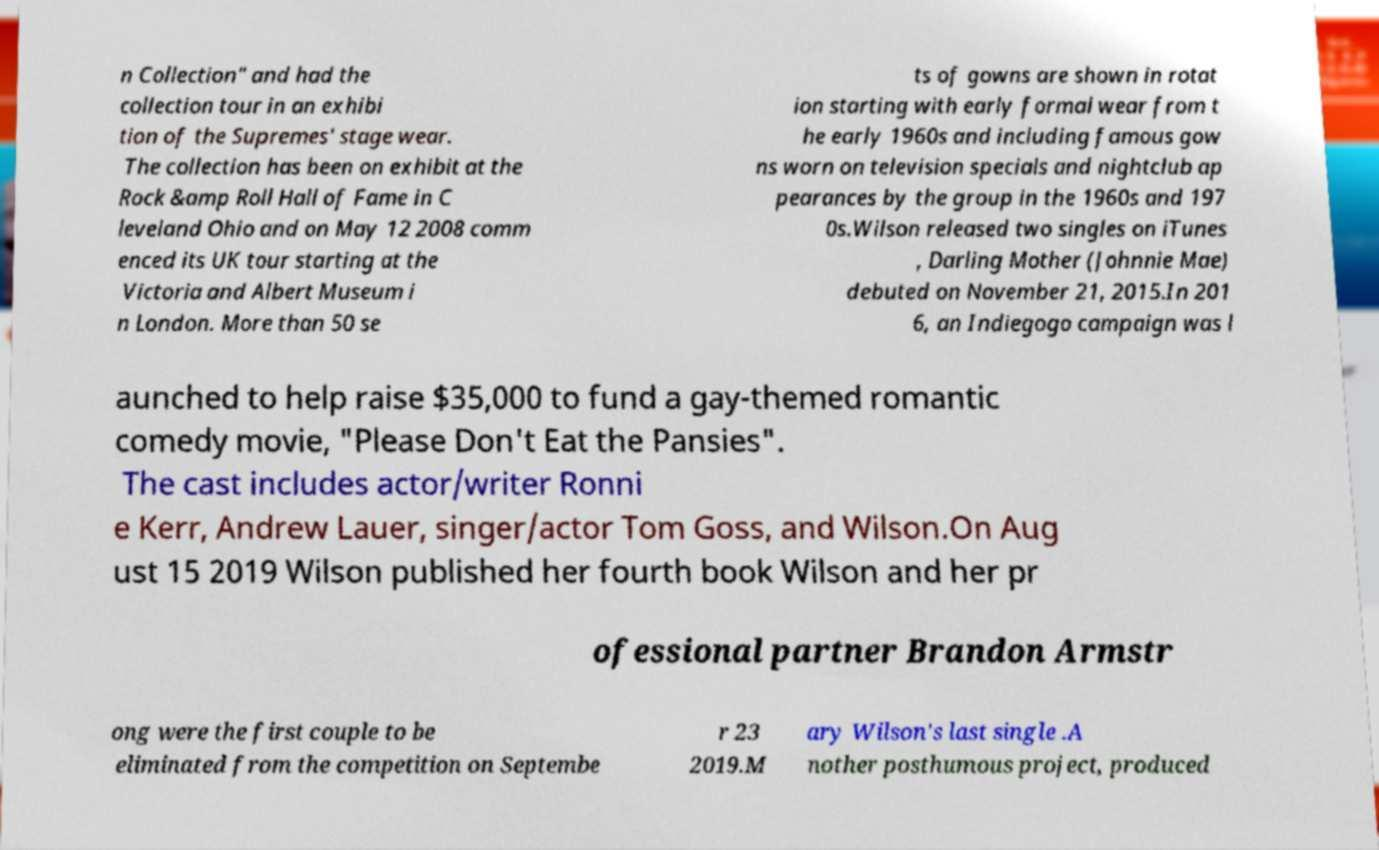Can you accurately transcribe the text from the provided image for me? n Collection" and had the collection tour in an exhibi tion of the Supremes' stage wear. The collection has been on exhibit at the Rock &amp Roll Hall of Fame in C leveland Ohio and on May 12 2008 comm enced its UK tour starting at the Victoria and Albert Museum i n London. More than 50 se ts of gowns are shown in rotat ion starting with early formal wear from t he early 1960s and including famous gow ns worn on television specials and nightclub ap pearances by the group in the 1960s and 197 0s.Wilson released two singles on iTunes , Darling Mother (Johnnie Mae) debuted on November 21, 2015.In 201 6, an Indiegogo campaign was l aunched to help raise $35,000 to fund a gay-themed romantic comedy movie, "Please Don't Eat the Pansies". The cast includes actor/writer Ronni e Kerr, Andrew Lauer, singer/actor Tom Goss, and Wilson.On Aug ust 15 2019 Wilson published her fourth book Wilson and her pr ofessional partner Brandon Armstr ong were the first couple to be eliminated from the competition on Septembe r 23 2019.M ary Wilson's last single .A nother posthumous project, produced 